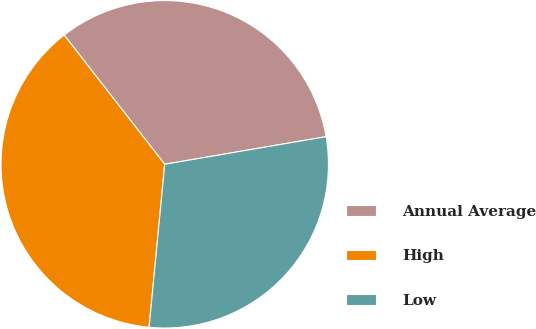Convert chart to OTSL. <chart><loc_0><loc_0><loc_500><loc_500><pie_chart><fcel>Annual Average<fcel>High<fcel>Low<nl><fcel>32.83%<fcel>37.95%<fcel>29.22%<nl></chart> 